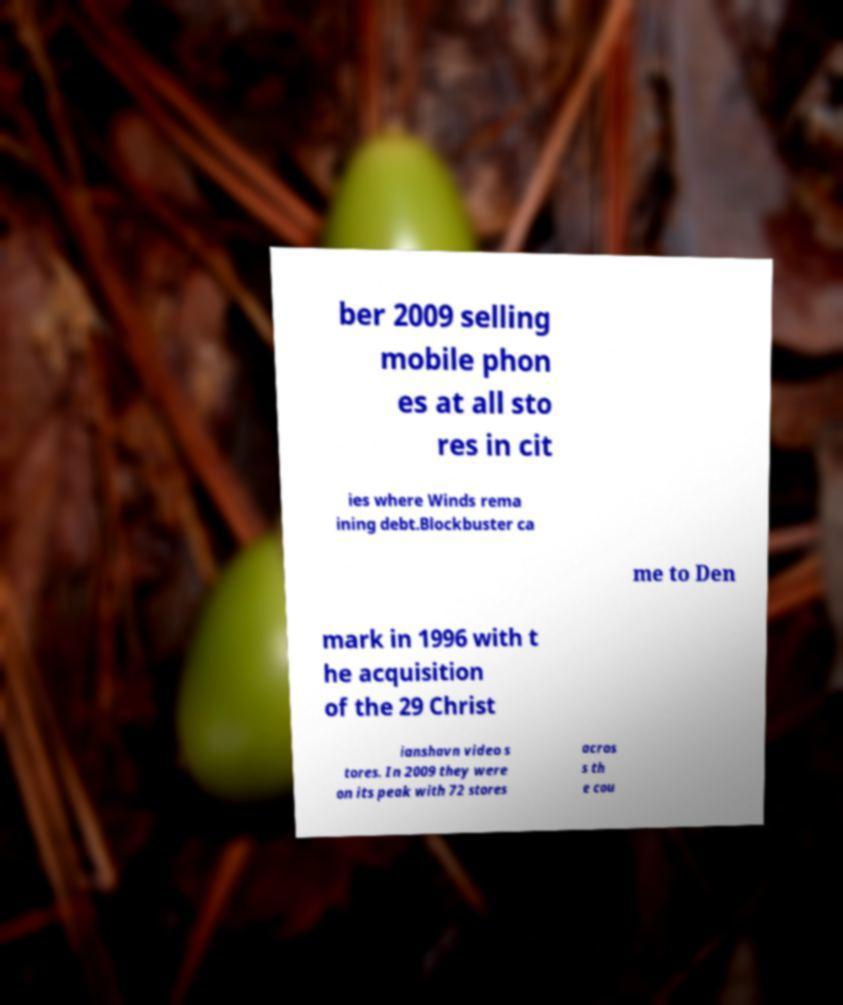Could you extract and type out the text from this image? ber 2009 selling mobile phon es at all sto res in cit ies where Winds rema ining debt.Blockbuster ca me to Den mark in 1996 with t he acquisition of the 29 Christ ianshavn video s tores. In 2009 they were on its peak with 72 stores acros s th e cou 